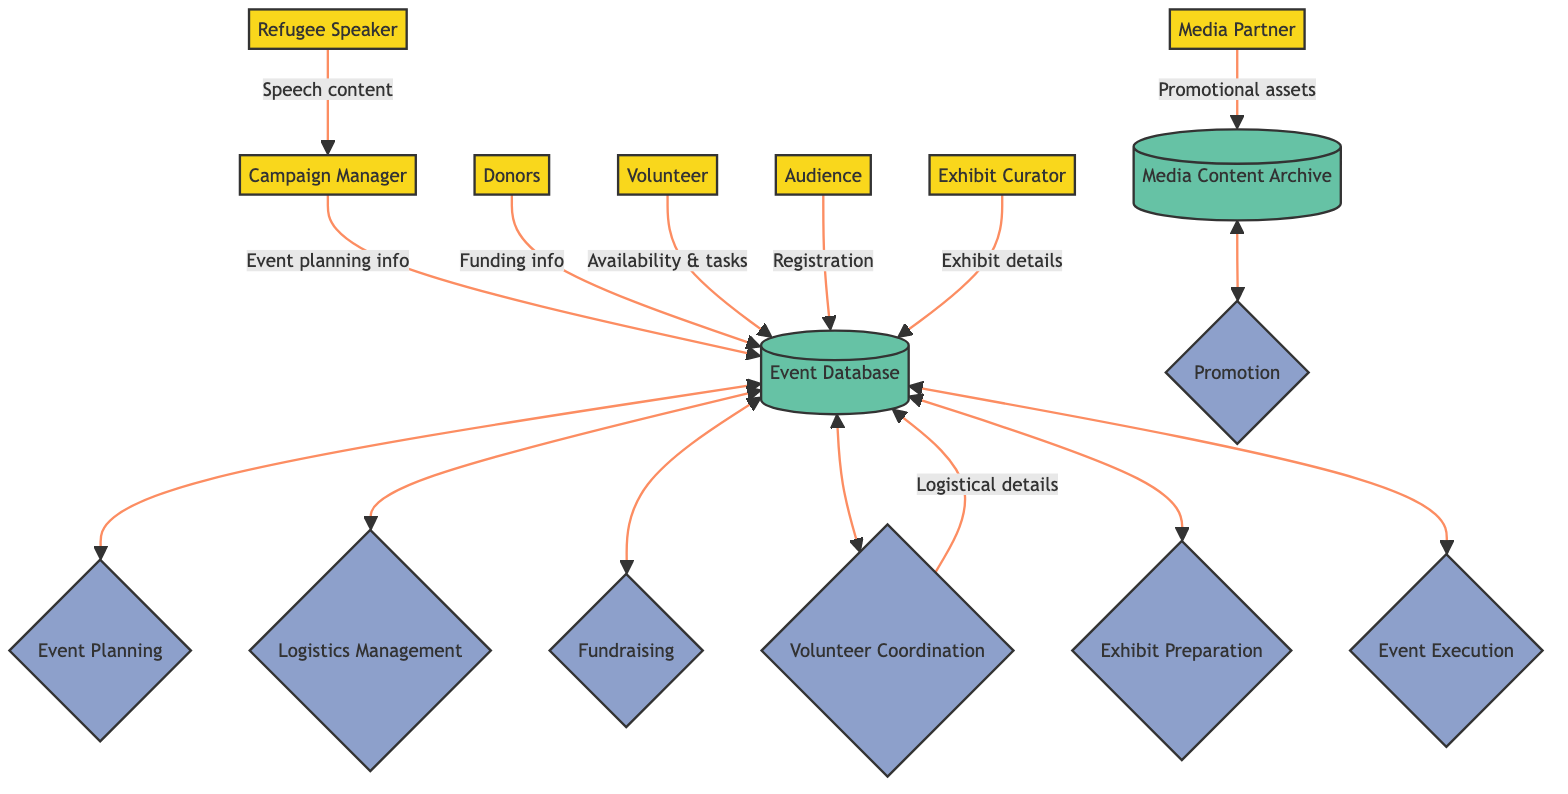What is the role of the Campaign Manager? The Campaign Manager is responsible for organizing and overseeing the awareness campaign. This basic information is derived from the entity description in the diagram.
Answer: Organizing and overseeing the awareness campaign How many data stores are in this diagram? The diagram includes two data stores labeled as Event Database and Media Content Archive. The counting of nodes identified as data stores leads to this conclusion.
Answer: 2 Which entity updates the logistical information? The Venue Coordinator updates logistical information as specified by the directed flow from this entity to the Event Database in the diagram.
Answer: Venue Coordinator How many processes are involved in the event management flow? There are seven processes identified including Event Planning, Promotion, Logistics Management, Fundraising, Volunteer Coordination, Exhibit Preparation, and Event Execution. Counting these processes gives the answer.
Answer: 7 What is the flow from Refugee Speaker to Campaign Manager? The Refugee Speaker sends speech content to the Campaign Manager as indicated by the directed flow represented in the diagram. This can be deduced from the specific data flow connection shown.
Answer: Speech content What does the Media Partner do in the event management process? The Media Partner uploads promotional assets into the Media Content Archive as shown in the diagram's data flow. This specific function is laid out clearly in the connection between these entities in the diagram.
Answer: Uploads promotional assets In which process does the Event Database participate most? The Event Database is involved in multiple processes such as Event Planning, Logistics Management, Fundraising, Volunteer Coordination, Exhibit Preparation, and Event Execution, indicating high participation. The mapping of interactions leads to the conclusion that it is central to all listed processes.
Answer: All processes Which entities are involved in the fundraising process? The Donors are directly related to the fundraising process as they provide funding information, indicated by the specific arrow flowing into the Event Database relevant to fundraising activities. This connection among the entities reveals their roles.
Answer: Donors 